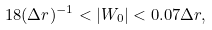Convert formula to latex. <formula><loc_0><loc_0><loc_500><loc_500>1 8 ( \Delta r ) ^ { - 1 } < | W _ { 0 } | < 0 . 0 7 \Delta r ,</formula> 